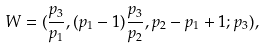Convert formula to latex. <formula><loc_0><loc_0><loc_500><loc_500>W = ( \frac { p _ { 3 } } { p _ { 1 } } , ( p _ { 1 } - 1 ) \frac { p _ { 3 } } { p _ { 2 } } , p _ { 2 } - p _ { 1 } + 1 ; p _ { 3 } ) ,</formula> 